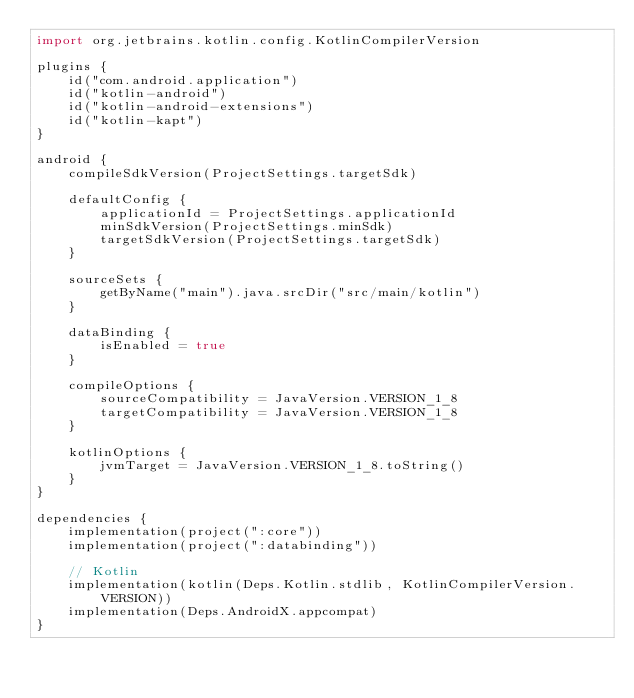Convert code to text. <code><loc_0><loc_0><loc_500><loc_500><_Kotlin_>import org.jetbrains.kotlin.config.KotlinCompilerVersion

plugins {
    id("com.android.application")
    id("kotlin-android")
    id("kotlin-android-extensions")
    id("kotlin-kapt")
}

android {
    compileSdkVersion(ProjectSettings.targetSdk)

    defaultConfig {
        applicationId = ProjectSettings.applicationId
        minSdkVersion(ProjectSettings.minSdk)
        targetSdkVersion(ProjectSettings.targetSdk)
    }

    sourceSets {
        getByName("main").java.srcDir("src/main/kotlin")
    }

    dataBinding {
        isEnabled = true
    }

    compileOptions {
        sourceCompatibility = JavaVersion.VERSION_1_8
        targetCompatibility = JavaVersion.VERSION_1_8
    }

    kotlinOptions {
        jvmTarget = JavaVersion.VERSION_1_8.toString()
    }
}

dependencies {
    implementation(project(":core"))
    implementation(project(":databinding"))

    // Kotlin
    implementation(kotlin(Deps.Kotlin.stdlib, KotlinCompilerVersion.VERSION))
    implementation(Deps.AndroidX.appcompat)
}
</code> 